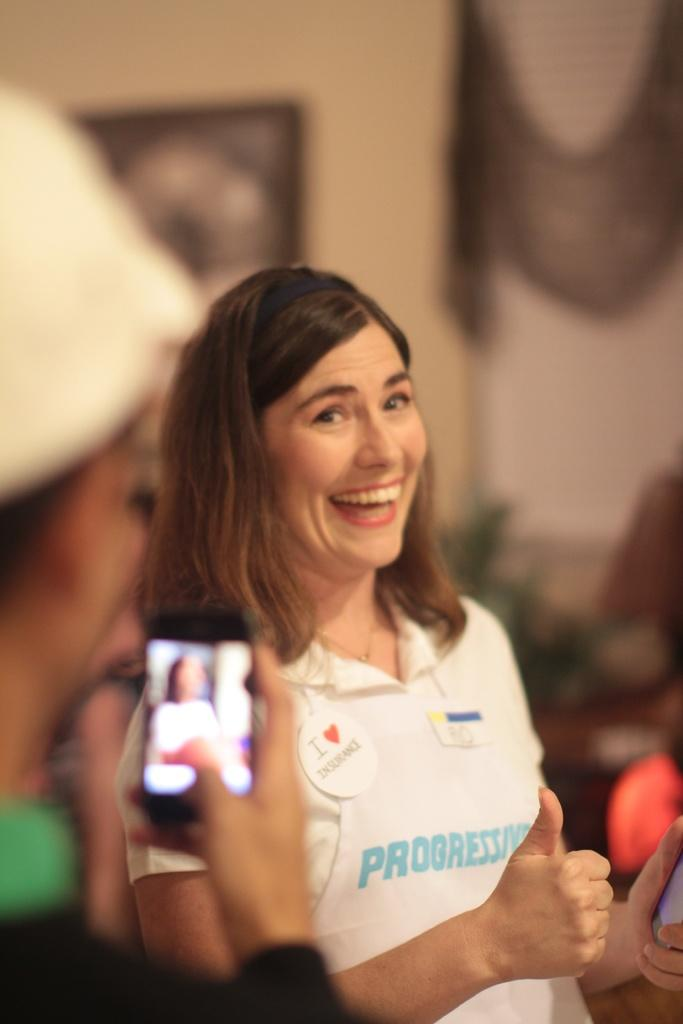Who is present in the image? There is a woman in the image. What is the woman doing in the image? The woman is smiling. Can you describe the person holding a mobile in the image? There is a person holding a mobile in the image. What is the condition of the background in the image? The background of the image is blurred. What type of flowers are being discussed in the class in the image? There is no class or discussion of flowers present in the image. 